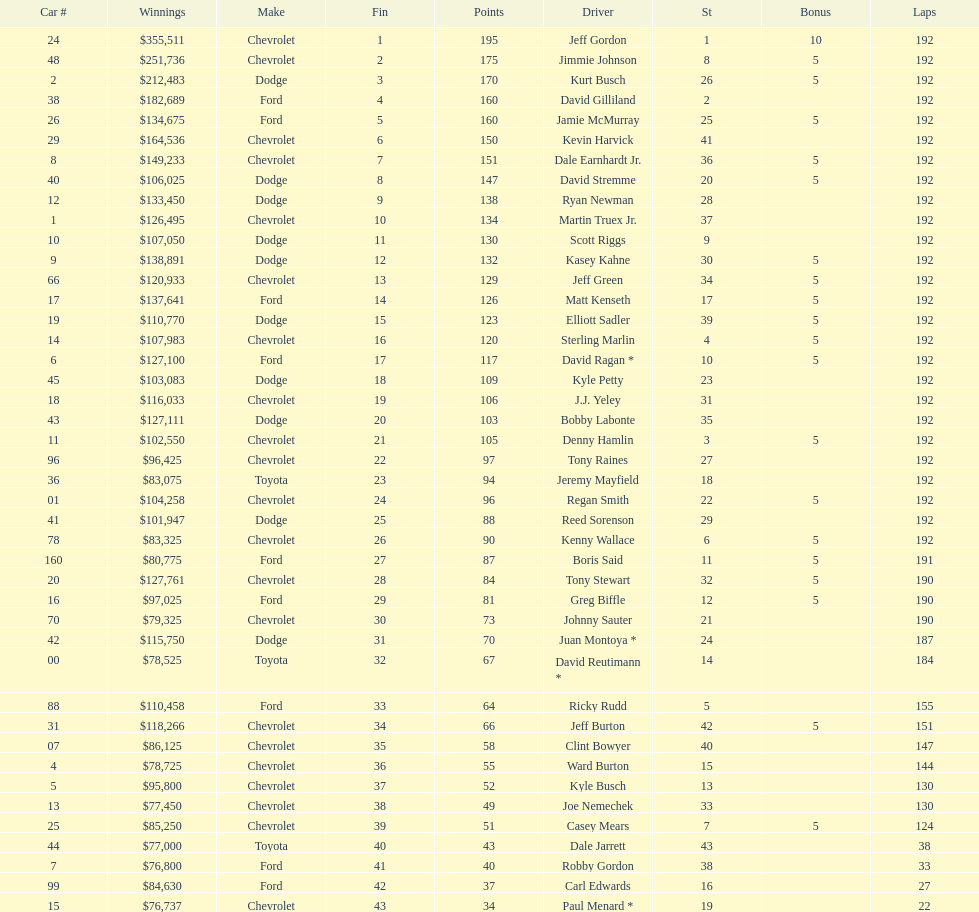How many drivers placed below tony stewart? 15. 